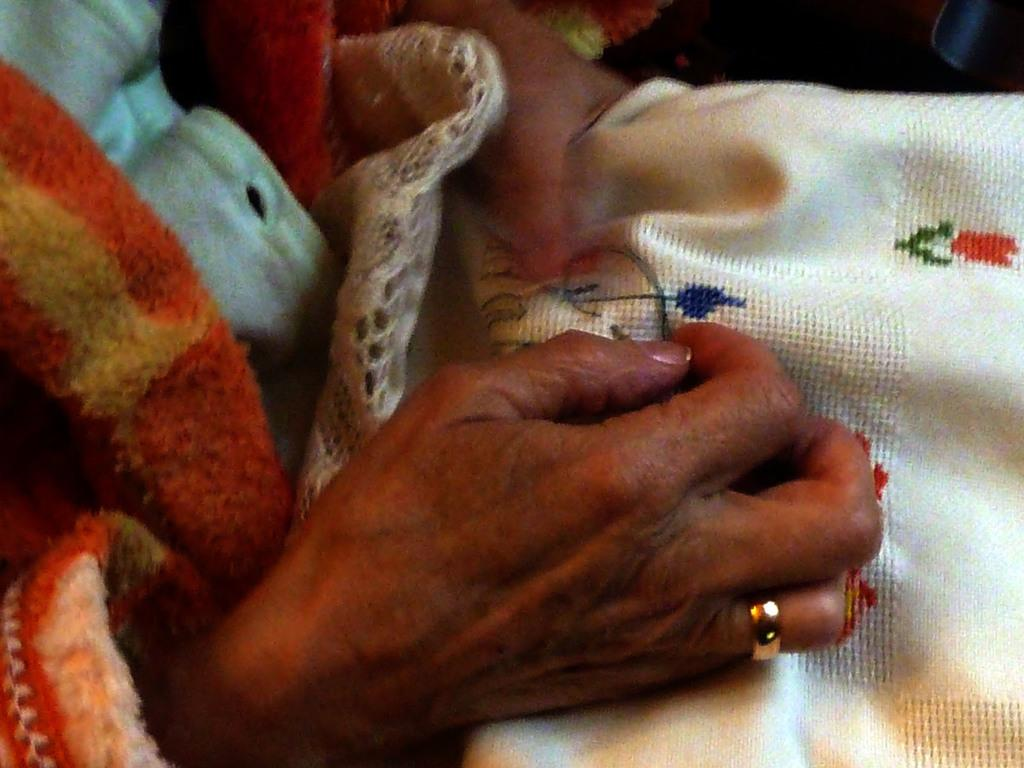What are the children playing with in the image? The children are playing with toys on the floor. Can you describe the toys that are visible in the image? There is a toy car, a teddy bear, and a dollhouse visible in the image. What type of skirt is the rabbit wearing in the image? There is no rabbit present in the image, and therefore no skirt can be observed. 